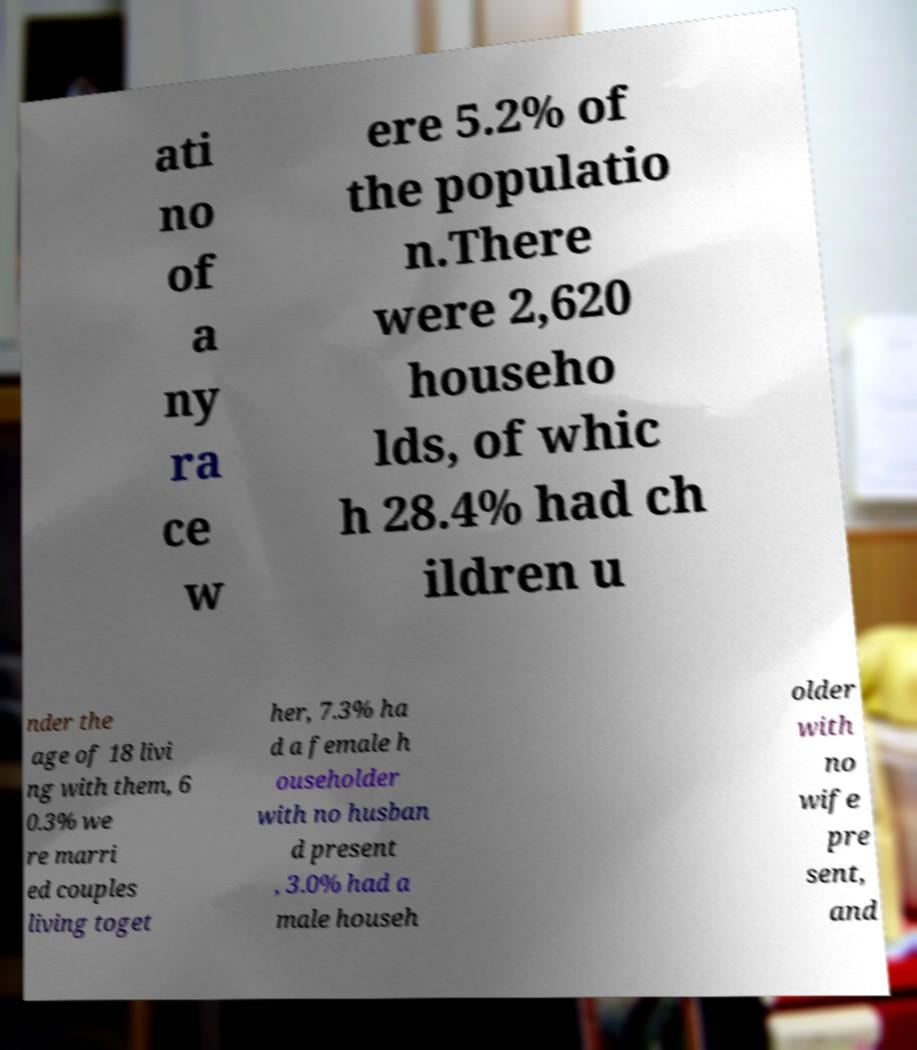I need the written content from this picture converted into text. Can you do that? ati no of a ny ra ce w ere 5.2% of the populatio n.There were 2,620 househo lds, of whic h 28.4% had ch ildren u nder the age of 18 livi ng with them, 6 0.3% we re marri ed couples living toget her, 7.3% ha d a female h ouseholder with no husban d present , 3.0% had a male househ older with no wife pre sent, and 